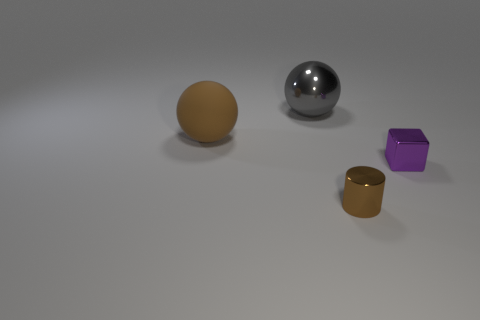Add 4 large red rubber cubes. How many objects exist? 8 Subtract all cylinders. How many objects are left? 3 Subtract 0 blue cylinders. How many objects are left? 4 Subtract all red metallic objects. Subtract all tiny brown shiny things. How many objects are left? 3 Add 2 brown cylinders. How many brown cylinders are left? 3 Add 3 shiny things. How many shiny things exist? 6 